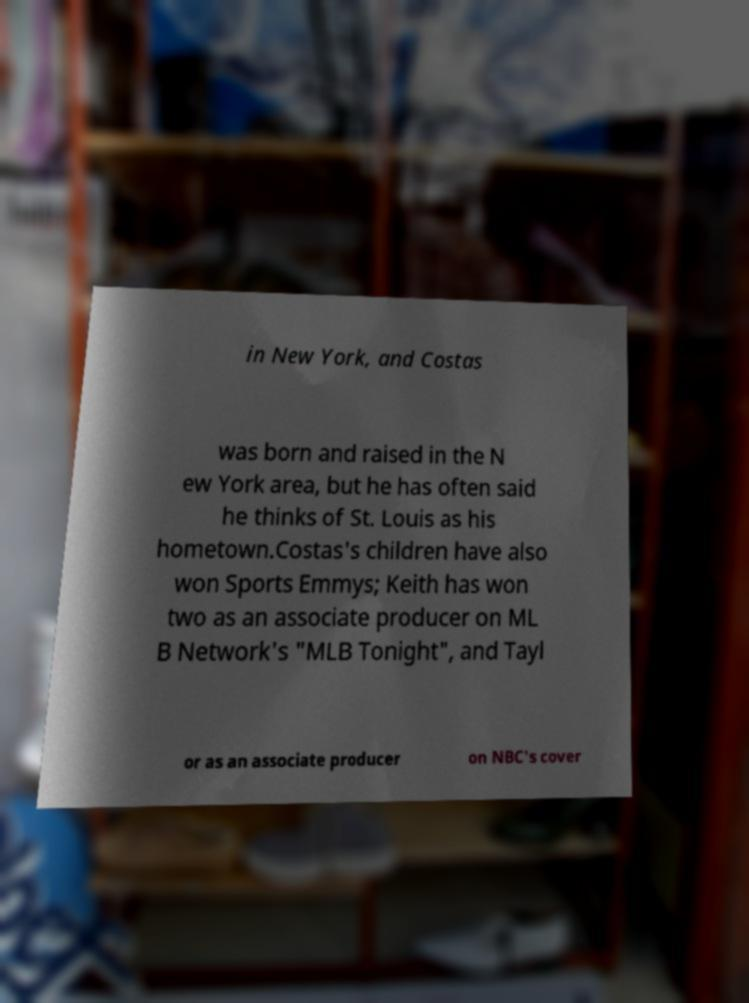What messages or text are displayed in this image? I need them in a readable, typed format. in New York, and Costas was born and raised in the N ew York area, but he has often said he thinks of St. Louis as his hometown.Costas's children have also won Sports Emmys; Keith has won two as an associate producer on ML B Network's "MLB Tonight", and Tayl or as an associate producer on NBC's cover 